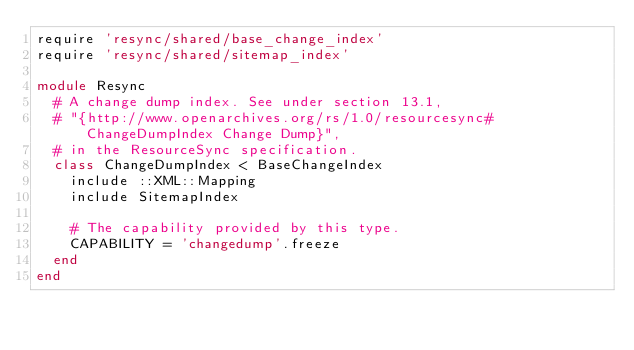Convert code to text. <code><loc_0><loc_0><loc_500><loc_500><_Ruby_>require 'resync/shared/base_change_index'
require 'resync/shared/sitemap_index'

module Resync
  # A change dump index. See under section 13.1,
  # "{http://www.openarchives.org/rs/1.0/resourcesync#ChangeDumpIndex Change Dump}",
  # in the ResourceSync specification.
  class ChangeDumpIndex < BaseChangeIndex
    include ::XML::Mapping
    include SitemapIndex

    # The capability provided by this type.
    CAPABILITY = 'changedump'.freeze
  end
end
</code> 